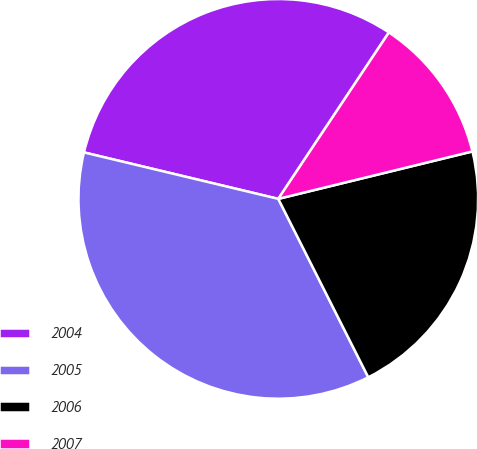Convert chart to OTSL. <chart><loc_0><loc_0><loc_500><loc_500><pie_chart><fcel>2004<fcel>2005<fcel>2006<fcel>2007<nl><fcel>30.6%<fcel>36.17%<fcel>21.38%<fcel>11.85%<nl></chart> 